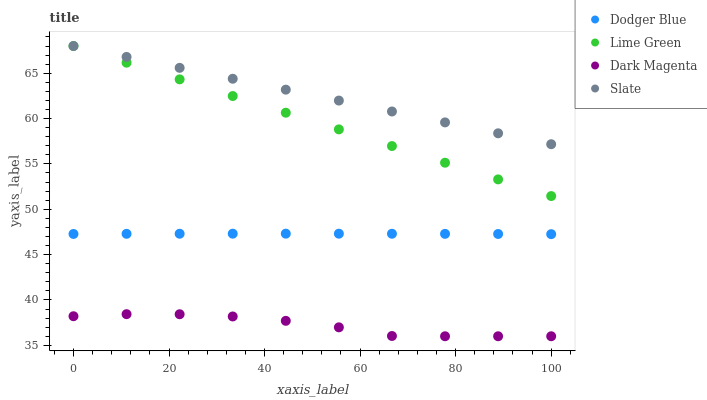Does Dark Magenta have the minimum area under the curve?
Answer yes or no. Yes. Does Slate have the maximum area under the curve?
Answer yes or no. Yes. Does Dodger Blue have the minimum area under the curve?
Answer yes or no. No. Does Dodger Blue have the maximum area under the curve?
Answer yes or no. No. Is Lime Green the smoothest?
Answer yes or no. Yes. Is Dark Magenta the roughest?
Answer yes or no. Yes. Is Slate the smoothest?
Answer yes or no. No. Is Slate the roughest?
Answer yes or no. No. Does Dark Magenta have the lowest value?
Answer yes or no. Yes. Does Dodger Blue have the lowest value?
Answer yes or no. No. Does Slate have the highest value?
Answer yes or no. Yes. Does Dodger Blue have the highest value?
Answer yes or no. No. Is Dodger Blue less than Lime Green?
Answer yes or no. Yes. Is Slate greater than Dodger Blue?
Answer yes or no. Yes. Does Lime Green intersect Slate?
Answer yes or no. Yes. Is Lime Green less than Slate?
Answer yes or no. No. Is Lime Green greater than Slate?
Answer yes or no. No. Does Dodger Blue intersect Lime Green?
Answer yes or no. No. 